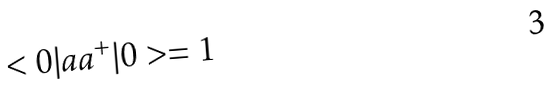Convert formula to latex. <formula><loc_0><loc_0><loc_500><loc_500>< 0 | a a ^ { + } | 0 > = 1</formula> 